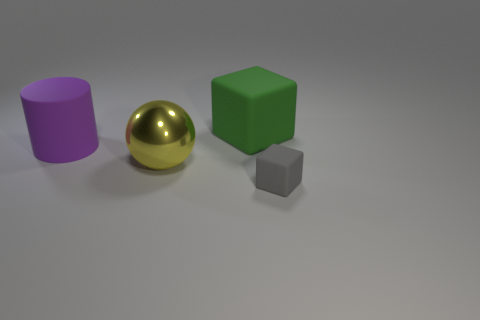There is a cube that is left of the rubber block in front of the block that is left of the small gray cube; what is its size?
Your response must be concise. Large. Are the gray block to the right of the purple thing and the large yellow object made of the same material?
Offer a terse response. No. Is there anything else that is the same shape as the yellow thing?
Offer a terse response. No. How many things are either tiny gray objects or things?
Your answer should be very brief. 4. What is the size of the other matte object that is the same shape as the small object?
Make the answer very short. Large. Are there any other things that have the same size as the gray rubber block?
Provide a succinct answer. No. What number of cubes are purple things or big yellow metallic things?
Offer a terse response. 0. There is a big rubber thing in front of the large matte thing right of the big cylinder; what is its color?
Your response must be concise. Purple. What shape is the green matte object?
Provide a succinct answer. Cube. Do the matte object that is behind the purple matte cylinder and the big cylinder have the same size?
Your answer should be very brief. Yes. 